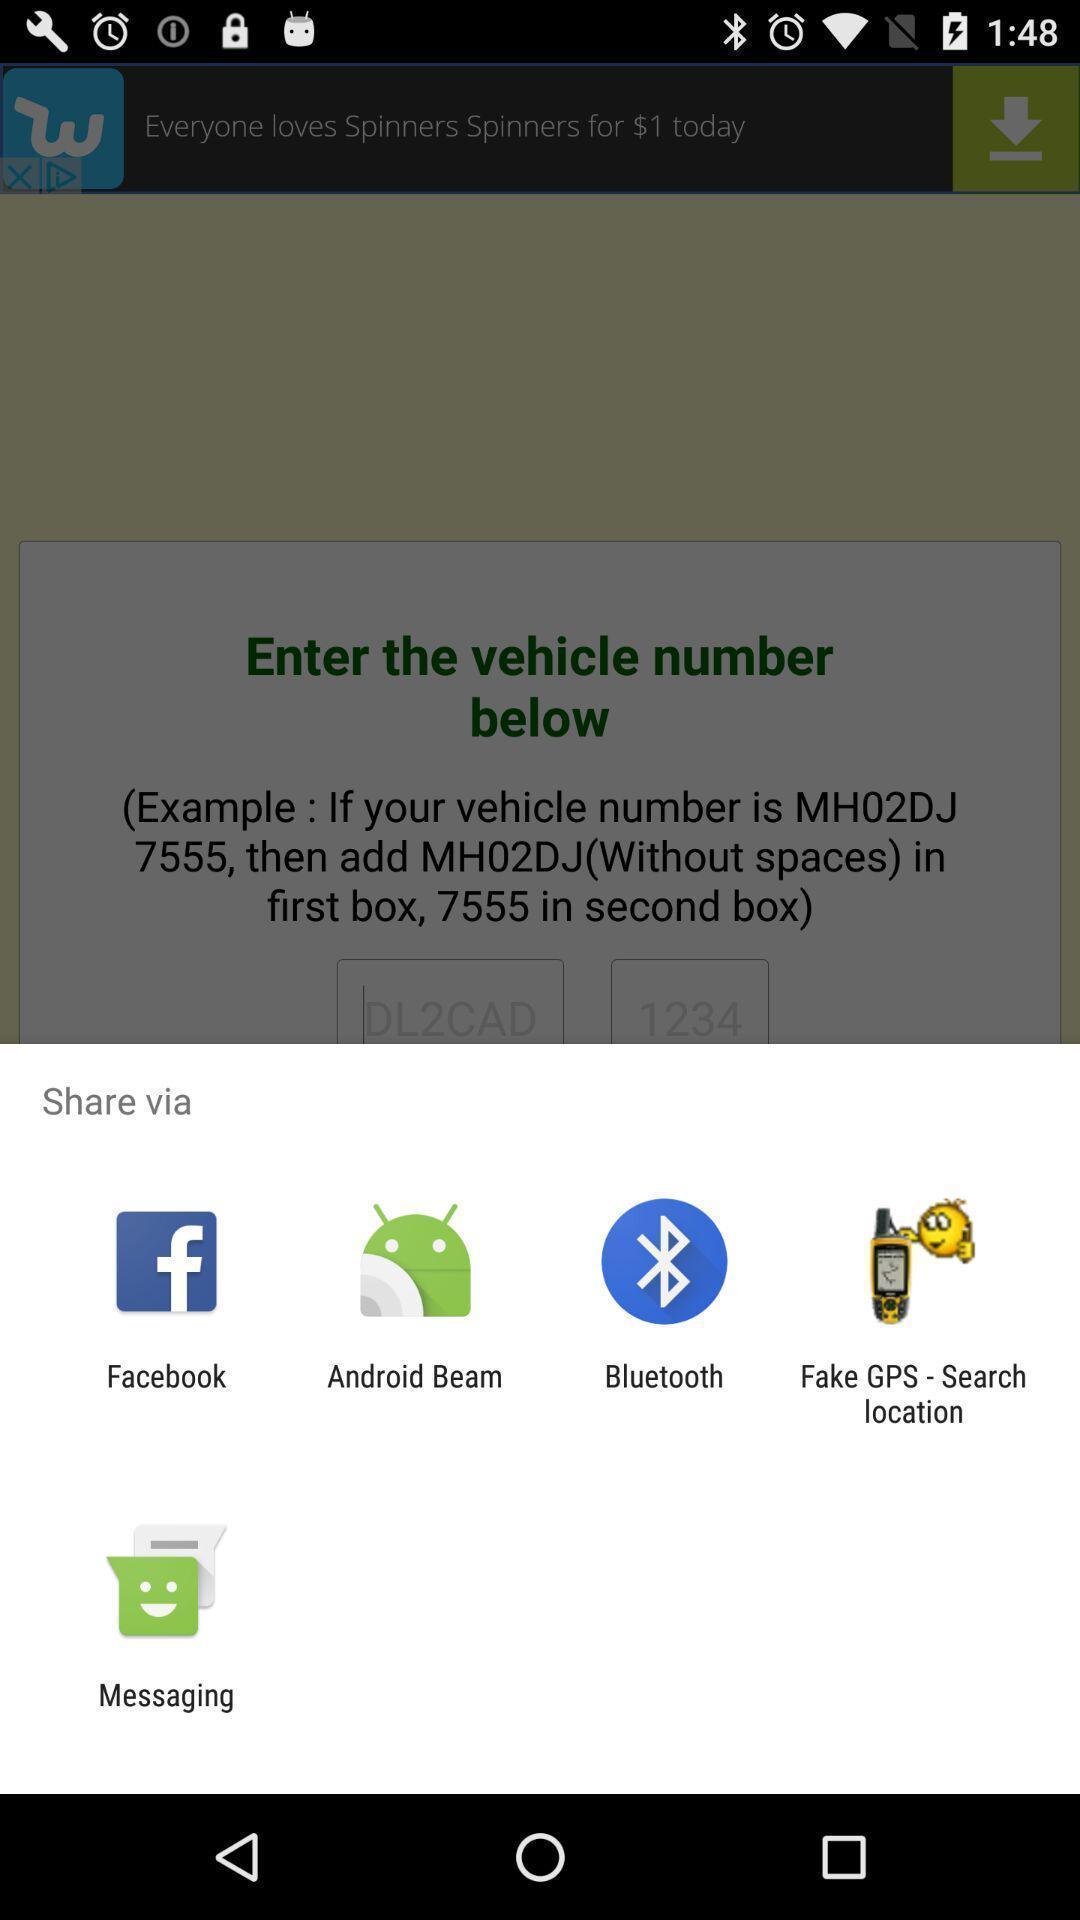Summarize the main components in this picture. Page showing pop-up to share. 